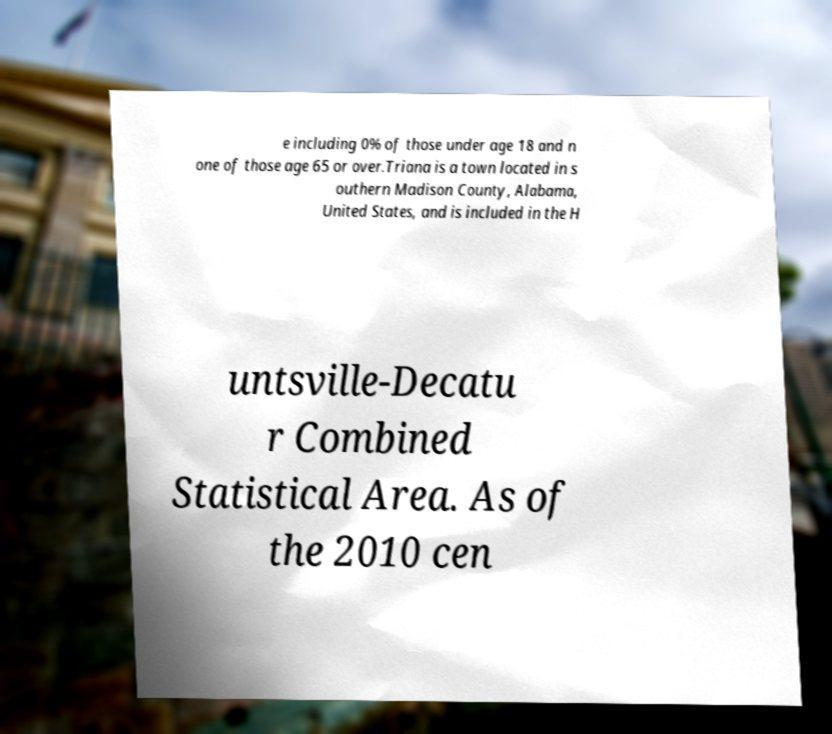What messages or text are displayed in this image? I need them in a readable, typed format. e including 0% of those under age 18 and n one of those age 65 or over.Triana is a town located in s outhern Madison County, Alabama, United States, and is included in the H untsville-Decatu r Combined Statistical Area. As of the 2010 cen 